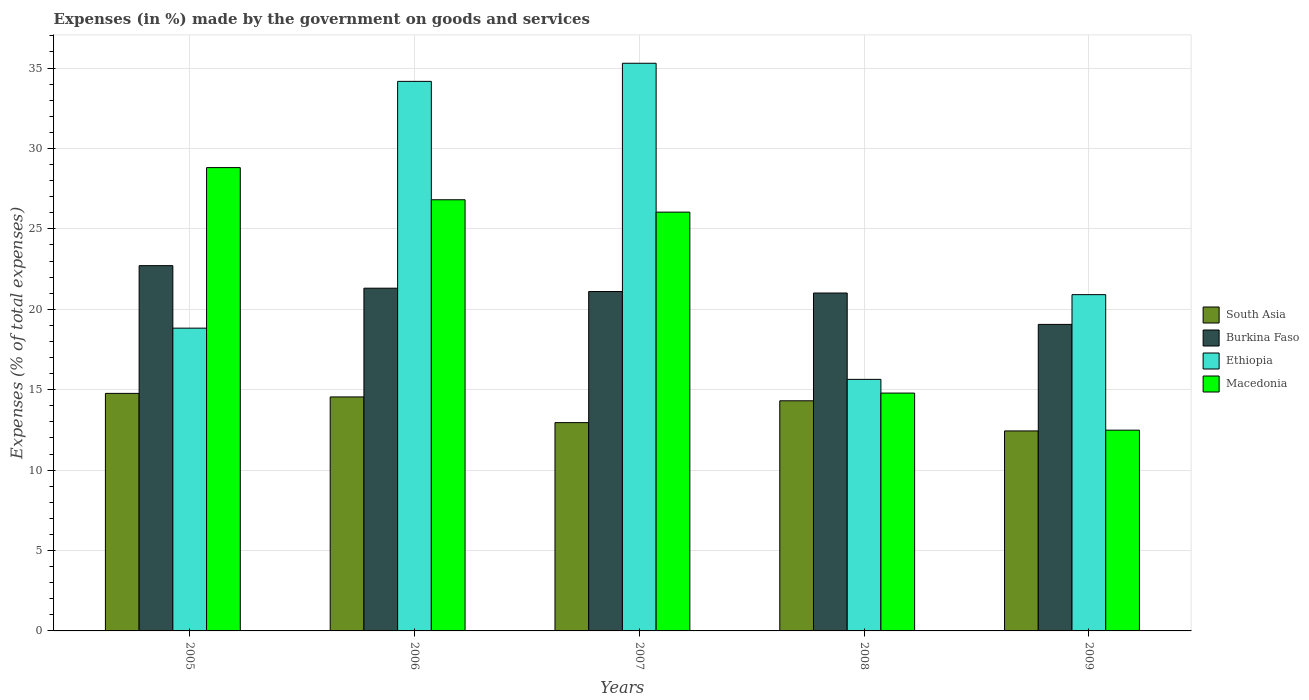How many groups of bars are there?
Make the answer very short. 5. How many bars are there on the 2nd tick from the left?
Offer a very short reply. 4. In how many cases, is the number of bars for a given year not equal to the number of legend labels?
Ensure brevity in your answer.  0. What is the percentage of expenses made by the government on goods and services in South Asia in 2008?
Your answer should be compact. 14.31. Across all years, what is the maximum percentage of expenses made by the government on goods and services in Ethiopia?
Your response must be concise. 35.3. Across all years, what is the minimum percentage of expenses made by the government on goods and services in South Asia?
Offer a terse response. 12.44. What is the total percentage of expenses made by the government on goods and services in Macedonia in the graph?
Provide a short and direct response. 108.93. What is the difference between the percentage of expenses made by the government on goods and services in Macedonia in 2006 and that in 2007?
Give a very brief answer. 0.77. What is the difference between the percentage of expenses made by the government on goods and services in South Asia in 2005 and the percentage of expenses made by the government on goods and services in Ethiopia in 2006?
Offer a very short reply. -19.4. What is the average percentage of expenses made by the government on goods and services in South Asia per year?
Provide a succinct answer. 13.8. In the year 2006, what is the difference between the percentage of expenses made by the government on goods and services in Macedonia and percentage of expenses made by the government on goods and services in Burkina Faso?
Your answer should be very brief. 5.5. In how many years, is the percentage of expenses made by the government on goods and services in Ethiopia greater than 2 %?
Give a very brief answer. 5. What is the ratio of the percentage of expenses made by the government on goods and services in Burkina Faso in 2005 to that in 2008?
Your answer should be compact. 1.08. What is the difference between the highest and the second highest percentage of expenses made by the government on goods and services in South Asia?
Your answer should be very brief. 0.22. What is the difference between the highest and the lowest percentage of expenses made by the government on goods and services in Burkina Faso?
Your answer should be compact. 3.65. Is the sum of the percentage of expenses made by the government on goods and services in South Asia in 2006 and 2009 greater than the maximum percentage of expenses made by the government on goods and services in Macedonia across all years?
Your answer should be compact. No. Is it the case that in every year, the sum of the percentage of expenses made by the government on goods and services in Macedonia and percentage of expenses made by the government on goods and services in South Asia is greater than the sum of percentage of expenses made by the government on goods and services in Ethiopia and percentage of expenses made by the government on goods and services in Burkina Faso?
Make the answer very short. No. What does the 3rd bar from the left in 2009 represents?
Your answer should be compact. Ethiopia. What does the 4th bar from the right in 2005 represents?
Your answer should be compact. South Asia. How many years are there in the graph?
Provide a succinct answer. 5. What is the difference between two consecutive major ticks on the Y-axis?
Provide a short and direct response. 5. Are the values on the major ticks of Y-axis written in scientific E-notation?
Your response must be concise. No. Does the graph contain any zero values?
Your answer should be compact. No. Where does the legend appear in the graph?
Offer a very short reply. Center right. How many legend labels are there?
Offer a very short reply. 4. What is the title of the graph?
Offer a terse response. Expenses (in %) made by the government on goods and services. What is the label or title of the Y-axis?
Offer a terse response. Expenses (% of total expenses). What is the Expenses (% of total expenses) in South Asia in 2005?
Your answer should be very brief. 14.77. What is the Expenses (% of total expenses) in Burkina Faso in 2005?
Give a very brief answer. 22.71. What is the Expenses (% of total expenses) of Ethiopia in 2005?
Give a very brief answer. 18.83. What is the Expenses (% of total expenses) in Macedonia in 2005?
Your answer should be very brief. 28.81. What is the Expenses (% of total expenses) in South Asia in 2006?
Keep it short and to the point. 14.55. What is the Expenses (% of total expenses) in Burkina Faso in 2006?
Provide a succinct answer. 21.31. What is the Expenses (% of total expenses) of Ethiopia in 2006?
Your answer should be very brief. 34.17. What is the Expenses (% of total expenses) of Macedonia in 2006?
Offer a very short reply. 26.81. What is the Expenses (% of total expenses) in South Asia in 2007?
Provide a short and direct response. 12.95. What is the Expenses (% of total expenses) in Burkina Faso in 2007?
Make the answer very short. 21.1. What is the Expenses (% of total expenses) of Ethiopia in 2007?
Offer a very short reply. 35.3. What is the Expenses (% of total expenses) in Macedonia in 2007?
Your response must be concise. 26.04. What is the Expenses (% of total expenses) of South Asia in 2008?
Make the answer very short. 14.31. What is the Expenses (% of total expenses) of Burkina Faso in 2008?
Your answer should be compact. 21.01. What is the Expenses (% of total expenses) in Ethiopia in 2008?
Your answer should be very brief. 15.64. What is the Expenses (% of total expenses) of Macedonia in 2008?
Provide a succinct answer. 14.79. What is the Expenses (% of total expenses) of South Asia in 2009?
Ensure brevity in your answer.  12.44. What is the Expenses (% of total expenses) in Burkina Faso in 2009?
Make the answer very short. 19.06. What is the Expenses (% of total expenses) of Ethiopia in 2009?
Ensure brevity in your answer.  20.91. What is the Expenses (% of total expenses) in Macedonia in 2009?
Make the answer very short. 12.48. Across all years, what is the maximum Expenses (% of total expenses) of South Asia?
Provide a succinct answer. 14.77. Across all years, what is the maximum Expenses (% of total expenses) of Burkina Faso?
Make the answer very short. 22.71. Across all years, what is the maximum Expenses (% of total expenses) in Ethiopia?
Your response must be concise. 35.3. Across all years, what is the maximum Expenses (% of total expenses) in Macedonia?
Give a very brief answer. 28.81. Across all years, what is the minimum Expenses (% of total expenses) of South Asia?
Make the answer very short. 12.44. Across all years, what is the minimum Expenses (% of total expenses) in Burkina Faso?
Keep it short and to the point. 19.06. Across all years, what is the minimum Expenses (% of total expenses) in Ethiopia?
Make the answer very short. 15.64. Across all years, what is the minimum Expenses (% of total expenses) of Macedonia?
Keep it short and to the point. 12.48. What is the total Expenses (% of total expenses) in South Asia in the graph?
Your answer should be compact. 69.01. What is the total Expenses (% of total expenses) in Burkina Faso in the graph?
Keep it short and to the point. 105.19. What is the total Expenses (% of total expenses) in Ethiopia in the graph?
Provide a succinct answer. 124.84. What is the total Expenses (% of total expenses) of Macedonia in the graph?
Give a very brief answer. 108.93. What is the difference between the Expenses (% of total expenses) of South Asia in 2005 and that in 2006?
Keep it short and to the point. 0.22. What is the difference between the Expenses (% of total expenses) in Burkina Faso in 2005 and that in 2006?
Your answer should be compact. 1.4. What is the difference between the Expenses (% of total expenses) in Ethiopia in 2005 and that in 2006?
Provide a short and direct response. -15.34. What is the difference between the Expenses (% of total expenses) in Macedonia in 2005 and that in 2006?
Ensure brevity in your answer.  2. What is the difference between the Expenses (% of total expenses) in South Asia in 2005 and that in 2007?
Give a very brief answer. 1.82. What is the difference between the Expenses (% of total expenses) of Burkina Faso in 2005 and that in 2007?
Your response must be concise. 1.61. What is the difference between the Expenses (% of total expenses) in Ethiopia in 2005 and that in 2007?
Your answer should be compact. -16.47. What is the difference between the Expenses (% of total expenses) in Macedonia in 2005 and that in 2007?
Your response must be concise. 2.77. What is the difference between the Expenses (% of total expenses) of South Asia in 2005 and that in 2008?
Keep it short and to the point. 0.46. What is the difference between the Expenses (% of total expenses) of Burkina Faso in 2005 and that in 2008?
Your response must be concise. 1.7. What is the difference between the Expenses (% of total expenses) in Ethiopia in 2005 and that in 2008?
Your answer should be compact. 3.19. What is the difference between the Expenses (% of total expenses) of Macedonia in 2005 and that in 2008?
Give a very brief answer. 14.02. What is the difference between the Expenses (% of total expenses) in South Asia in 2005 and that in 2009?
Your answer should be very brief. 2.33. What is the difference between the Expenses (% of total expenses) of Burkina Faso in 2005 and that in 2009?
Give a very brief answer. 3.65. What is the difference between the Expenses (% of total expenses) of Ethiopia in 2005 and that in 2009?
Your response must be concise. -2.08. What is the difference between the Expenses (% of total expenses) of Macedonia in 2005 and that in 2009?
Provide a short and direct response. 16.33. What is the difference between the Expenses (% of total expenses) of South Asia in 2006 and that in 2007?
Your response must be concise. 1.6. What is the difference between the Expenses (% of total expenses) in Burkina Faso in 2006 and that in 2007?
Keep it short and to the point. 0.21. What is the difference between the Expenses (% of total expenses) in Ethiopia in 2006 and that in 2007?
Your answer should be compact. -1.13. What is the difference between the Expenses (% of total expenses) in Macedonia in 2006 and that in 2007?
Make the answer very short. 0.77. What is the difference between the Expenses (% of total expenses) of South Asia in 2006 and that in 2008?
Your answer should be compact. 0.24. What is the difference between the Expenses (% of total expenses) of Burkina Faso in 2006 and that in 2008?
Give a very brief answer. 0.3. What is the difference between the Expenses (% of total expenses) in Ethiopia in 2006 and that in 2008?
Offer a terse response. 18.53. What is the difference between the Expenses (% of total expenses) of Macedonia in 2006 and that in 2008?
Provide a succinct answer. 12.02. What is the difference between the Expenses (% of total expenses) of South Asia in 2006 and that in 2009?
Your answer should be very brief. 2.11. What is the difference between the Expenses (% of total expenses) of Burkina Faso in 2006 and that in 2009?
Offer a terse response. 2.25. What is the difference between the Expenses (% of total expenses) of Ethiopia in 2006 and that in 2009?
Make the answer very short. 13.26. What is the difference between the Expenses (% of total expenses) of Macedonia in 2006 and that in 2009?
Keep it short and to the point. 14.33. What is the difference between the Expenses (% of total expenses) of South Asia in 2007 and that in 2008?
Provide a short and direct response. -1.36. What is the difference between the Expenses (% of total expenses) of Burkina Faso in 2007 and that in 2008?
Keep it short and to the point. 0.09. What is the difference between the Expenses (% of total expenses) of Ethiopia in 2007 and that in 2008?
Your response must be concise. 19.65. What is the difference between the Expenses (% of total expenses) in Macedonia in 2007 and that in 2008?
Provide a succinct answer. 11.25. What is the difference between the Expenses (% of total expenses) of South Asia in 2007 and that in 2009?
Provide a succinct answer. 0.52. What is the difference between the Expenses (% of total expenses) of Burkina Faso in 2007 and that in 2009?
Your answer should be very brief. 2.04. What is the difference between the Expenses (% of total expenses) in Ethiopia in 2007 and that in 2009?
Provide a succinct answer. 14.39. What is the difference between the Expenses (% of total expenses) in Macedonia in 2007 and that in 2009?
Your answer should be compact. 13.56. What is the difference between the Expenses (% of total expenses) of South Asia in 2008 and that in 2009?
Make the answer very short. 1.87. What is the difference between the Expenses (% of total expenses) of Burkina Faso in 2008 and that in 2009?
Provide a succinct answer. 1.95. What is the difference between the Expenses (% of total expenses) in Ethiopia in 2008 and that in 2009?
Your response must be concise. -5.27. What is the difference between the Expenses (% of total expenses) in Macedonia in 2008 and that in 2009?
Offer a terse response. 2.31. What is the difference between the Expenses (% of total expenses) in South Asia in 2005 and the Expenses (% of total expenses) in Burkina Faso in 2006?
Your answer should be compact. -6.54. What is the difference between the Expenses (% of total expenses) in South Asia in 2005 and the Expenses (% of total expenses) in Ethiopia in 2006?
Your response must be concise. -19.4. What is the difference between the Expenses (% of total expenses) in South Asia in 2005 and the Expenses (% of total expenses) in Macedonia in 2006?
Your answer should be compact. -12.04. What is the difference between the Expenses (% of total expenses) of Burkina Faso in 2005 and the Expenses (% of total expenses) of Ethiopia in 2006?
Keep it short and to the point. -11.46. What is the difference between the Expenses (% of total expenses) of Burkina Faso in 2005 and the Expenses (% of total expenses) of Macedonia in 2006?
Offer a terse response. -4.1. What is the difference between the Expenses (% of total expenses) in Ethiopia in 2005 and the Expenses (% of total expenses) in Macedonia in 2006?
Your answer should be very brief. -7.98. What is the difference between the Expenses (% of total expenses) in South Asia in 2005 and the Expenses (% of total expenses) in Burkina Faso in 2007?
Give a very brief answer. -6.33. What is the difference between the Expenses (% of total expenses) of South Asia in 2005 and the Expenses (% of total expenses) of Ethiopia in 2007?
Provide a short and direct response. -20.53. What is the difference between the Expenses (% of total expenses) in South Asia in 2005 and the Expenses (% of total expenses) in Macedonia in 2007?
Give a very brief answer. -11.27. What is the difference between the Expenses (% of total expenses) of Burkina Faso in 2005 and the Expenses (% of total expenses) of Ethiopia in 2007?
Offer a very short reply. -12.58. What is the difference between the Expenses (% of total expenses) of Burkina Faso in 2005 and the Expenses (% of total expenses) of Macedonia in 2007?
Make the answer very short. -3.33. What is the difference between the Expenses (% of total expenses) of Ethiopia in 2005 and the Expenses (% of total expenses) of Macedonia in 2007?
Keep it short and to the point. -7.21. What is the difference between the Expenses (% of total expenses) of South Asia in 2005 and the Expenses (% of total expenses) of Burkina Faso in 2008?
Make the answer very short. -6.24. What is the difference between the Expenses (% of total expenses) in South Asia in 2005 and the Expenses (% of total expenses) in Ethiopia in 2008?
Ensure brevity in your answer.  -0.87. What is the difference between the Expenses (% of total expenses) in South Asia in 2005 and the Expenses (% of total expenses) in Macedonia in 2008?
Ensure brevity in your answer.  -0.02. What is the difference between the Expenses (% of total expenses) of Burkina Faso in 2005 and the Expenses (% of total expenses) of Ethiopia in 2008?
Provide a short and direct response. 7.07. What is the difference between the Expenses (% of total expenses) of Burkina Faso in 2005 and the Expenses (% of total expenses) of Macedonia in 2008?
Your response must be concise. 7.92. What is the difference between the Expenses (% of total expenses) of Ethiopia in 2005 and the Expenses (% of total expenses) of Macedonia in 2008?
Give a very brief answer. 4.04. What is the difference between the Expenses (% of total expenses) of South Asia in 2005 and the Expenses (% of total expenses) of Burkina Faso in 2009?
Give a very brief answer. -4.29. What is the difference between the Expenses (% of total expenses) in South Asia in 2005 and the Expenses (% of total expenses) in Ethiopia in 2009?
Keep it short and to the point. -6.14. What is the difference between the Expenses (% of total expenses) in South Asia in 2005 and the Expenses (% of total expenses) in Macedonia in 2009?
Make the answer very short. 2.29. What is the difference between the Expenses (% of total expenses) in Burkina Faso in 2005 and the Expenses (% of total expenses) in Ethiopia in 2009?
Your answer should be compact. 1.8. What is the difference between the Expenses (% of total expenses) of Burkina Faso in 2005 and the Expenses (% of total expenses) of Macedonia in 2009?
Make the answer very short. 10.23. What is the difference between the Expenses (% of total expenses) in Ethiopia in 2005 and the Expenses (% of total expenses) in Macedonia in 2009?
Provide a short and direct response. 6.34. What is the difference between the Expenses (% of total expenses) of South Asia in 2006 and the Expenses (% of total expenses) of Burkina Faso in 2007?
Your response must be concise. -6.55. What is the difference between the Expenses (% of total expenses) of South Asia in 2006 and the Expenses (% of total expenses) of Ethiopia in 2007?
Ensure brevity in your answer.  -20.75. What is the difference between the Expenses (% of total expenses) of South Asia in 2006 and the Expenses (% of total expenses) of Macedonia in 2007?
Make the answer very short. -11.49. What is the difference between the Expenses (% of total expenses) of Burkina Faso in 2006 and the Expenses (% of total expenses) of Ethiopia in 2007?
Your response must be concise. -13.99. What is the difference between the Expenses (% of total expenses) in Burkina Faso in 2006 and the Expenses (% of total expenses) in Macedonia in 2007?
Provide a short and direct response. -4.73. What is the difference between the Expenses (% of total expenses) of Ethiopia in 2006 and the Expenses (% of total expenses) of Macedonia in 2007?
Provide a short and direct response. 8.13. What is the difference between the Expenses (% of total expenses) of South Asia in 2006 and the Expenses (% of total expenses) of Burkina Faso in 2008?
Provide a short and direct response. -6.46. What is the difference between the Expenses (% of total expenses) in South Asia in 2006 and the Expenses (% of total expenses) in Ethiopia in 2008?
Provide a succinct answer. -1.09. What is the difference between the Expenses (% of total expenses) of South Asia in 2006 and the Expenses (% of total expenses) of Macedonia in 2008?
Your answer should be very brief. -0.24. What is the difference between the Expenses (% of total expenses) of Burkina Faso in 2006 and the Expenses (% of total expenses) of Ethiopia in 2008?
Your response must be concise. 5.67. What is the difference between the Expenses (% of total expenses) of Burkina Faso in 2006 and the Expenses (% of total expenses) of Macedonia in 2008?
Ensure brevity in your answer.  6.52. What is the difference between the Expenses (% of total expenses) of Ethiopia in 2006 and the Expenses (% of total expenses) of Macedonia in 2008?
Offer a terse response. 19.38. What is the difference between the Expenses (% of total expenses) of South Asia in 2006 and the Expenses (% of total expenses) of Burkina Faso in 2009?
Your answer should be very brief. -4.51. What is the difference between the Expenses (% of total expenses) in South Asia in 2006 and the Expenses (% of total expenses) in Ethiopia in 2009?
Offer a terse response. -6.36. What is the difference between the Expenses (% of total expenses) in South Asia in 2006 and the Expenses (% of total expenses) in Macedonia in 2009?
Offer a terse response. 2.07. What is the difference between the Expenses (% of total expenses) in Burkina Faso in 2006 and the Expenses (% of total expenses) in Ethiopia in 2009?
Provide a succinct answer. 0.4. What is the difference between the Expenses (% of total expenses) in Burkina Faso in 2006 and the Expenses (% of total expenses) in Macedonia in 2009?
Give a very brief answer. 8.83. What is the difference between the Expenses (% of total expenses) of Ethiopia in 2006 and the Expenses (% of total expenses) of Macedonia in 2009?
Your response must be concise. 21.69. What is the difference between the Expenses (% of total expenses) in South Asia in 2007 and the Expenses (% of total expenses) in Burkina Faso in 2008?
Give a very brief answer. -8.06. What is the difference between the Expenses (% of total expenses) in South Asia in 2007 and the Expenses (% of total expenses) in Ethiopia in 2008?
Provide a succinct answer. -2.69. What is the difference between the Expenses (% of total expenses) in South Asia in 2007 and the Expenses (% of total expenses) in Macedonia in 2008?
Provide a succinct answer. -1.84. What is the difference between the Expenses (% of total expenses) in Burkina Faso in 2007 and the Expenses (% of total expenses) in Ethiopia in 2008?
Ensure brevity in your answer.  5.46. What is the difference between the Expenses (% of total expenses) in Burkina Faso in 2007 and the Expenses (% of total expenses) in Macedonia in 2008?
Your response must be concise. 6.31. What is the difference between the Expenses (% of total expenses) of Ethiopia in 2007 and the Expenses (% of total expenses) of Macedonia in 2008?
Offer a very short reply. 20.51. What is the difference between the Expenses (% of total expenses) in South Asia in 2007 and the Expenses (% of total expenses) in Burkina Faso in 2009?
Ensure brevity in your answer.  -6.11. What is the difference between the Expenses (% of total expenses) of South Asia in 2007 and the Expenses (% of total expenses) of Ethiopia in 2009?
Keep it short and to the point. -7.96. What is the difference between the Expenses (% of total expenses) in South Asia in 2007 and the Expenses (% of total expenses) in Macedonia in 2009?
Make the answer very short. 0.47. What is the difference between the Expenses (% of total expenses) of Burkina Faso in 2007 and the Expenses (% of total expenses) of Ethiopia in 2009?
Keep it short and to the point. 0.19. What is the difference between the Expenses (% of total expenses) in Burkina Faso in 2007 and the Expenses (% of total expenses) in Macedonia in 2009?
Keep it short and to the point. 8.62. What is the difference between the Expenses (% of total expenses) in Ethiopia in 2007 and the Expenses (% of total expenses) in Macedonia in 2009?
Ensure brevity in your answer.  22.81. What is the difference between the Expenses (% of total expenses) in South Asia in 2008 and the Expenses (% of total expenses) in Burkina Faso in 2009?
Make the answer very short. -4.75. What is the difference between the Expenses (% of total expenses) in South Asia in 2008 and the Expenses (% of total expenses) in Macedonia in 2009?
Your answer should be very brief. 1.83. What is the difference between the Expenses (% of total expenses) in Burkina Faso in 2008 and the Expenses (% of total expenses) in Ethiopia in 2009?
Your answer should be very brief. 0.1. What is the difference between the Expenses (% of total expenses) in Burkina Faso in 2008 and the Expenses (% of total expenses) in Macedonia in 2009?
Ensure brevity in your answer.  8.53. What is the difference between the Expenses (% of total expenses) in Ethiopia in 2008 and the Expenses (% of total expenses) in Macedonia in 2009?
Offer a very short reply. 3.16. What is the average Expenses (% of total expenses) of South Asia per year?
Your answer should be very brief. 13.8. What is the average Expenses (% of total expenses) of Burkina Faso per year?
Keep it short and to the point. 21.04. What is the average Expenses (% of total expenses) of Ethiopia per year?
Give a very brief answer. 24.97. What is the average Expenses (% of total expenses) in Macedonia per year?
Your answer should be compact. 21.79. In the year 2005, what is the difference between the Expenses (% of total expenses) of South Asia and Expenses (% of total expenses) of Burkina Faso?
Your response must be concise. -7.94. In the year 2005, what is the difference between the Expenses (% of total expenses) of South Asia and Expenses (% of total expenses) of Ethiopia?
Provide a succinct answer. -4.06. In the year 2005, what is the difference between the Expenses (% of total expenses) of South Asia and Expenses (% of total expenses) of Macedonia?
Make the answer very short. -14.04. In the year 2005, what is the difference between the Expenses (% of total expenses) of Burkina Faso and Expenses (% of total expenses) of Ethiopia?
Your answer should be very brief. 3.89. In the year 2005, what is the difference between the Expenses (% of total expenses) of Burkina Faso and Expenses (% of total expenses) of Macedonia?
Ensure brevity in your answer.  -6.1. In the year 2005, what is the difference between the Expenses (% of total expenses) of Ethiopia and Expenses (% of total expenses) of Macedonia?
Your answer should be very brief. -9.98. In the year 2006, what is the difference between the Expenses (% of total expenses) in South Asia and Expenses (% of total expenses) in Burkina Faso?
Give a very brief answer. -6.76. In the year 2006, what is the difference between the Expenses (% of total expenses) in South Asia and Expenses (% of total expenses) in Ethiopia?
Provide a short and direct response. -19.62. In the year 2006, what is the difference between the Expenses (% of total expenses) of South Asia and Expenses (% of total expenses) of Macedonia?
Provide a short and direct response. -12.26. In the year 2006, what is the difference between the Expenses (% of total expenses) of Burkina Faso and Expenses (% of total expenses) of Ethiopia?
Give a very brief answer. -12.86. In the year 2006, what is the difference between the Expenses (% of total expenses) of Burkina Faso and Expenses (% of total expenses) of Macedonia?
Offer a very short reply. -5.5. In the year 2006, what is the difference between the Expenses (% of total expenses) in Ethiopia and Expenses (% of total expenses) in Macedonia?
Your response must be concise. 7.36. In the year 2007, what is the difference between the Expenses (% of total expenses) of South Asia and Expenses (% of total expenses) of Burkina Faso?
Your answer should be compact. -8.15. In the year 2007, what is the difference between the Expenses (% of total expenses) in South Asia and Expenses (% of total expenses) in Ethiopia?
Your answer should be very brief. -22.34. In the year 2007, what is the difference between the Expenses (% of total expenses) in South Asia and Expenses (% of total expenses) in Macedonia?
Your answer should be compact. -13.09. In the year 2007, what is the difference between the Expenses (% of total expenses) in Burkina Faso and Expenses (% of total expenses) in Ethiopia?
Offer a very short reply. -14.19. In the year 2007, what is the difference between the Expenses (% of total expenses) of Burkina Faso and Expenses (% of total expenses) of Macedonia?
Offer a very short reply. -4.94. In the year 2007, what is the difference between the Expenses (% of total expenses) in Ethiopia and Expenses (% of total expenses) in Macedonia?
Provide a succinct answer. 9.26. In the year 2008, what is the difference between the Expenses (% of total expenses) in South Asia and Expenses (% of total expenses) in Burkina Faso?
Make the answer very short. -6.7. In the year 2008, what is the difference between the Expenses (% of total expenses) in South Asia and Expenses (% of total expenses) in Ethiopia?
Provide a succinct answer. -1.33. In the year 2008, what is the difference between the Expenses (% of total expenses) in South Asia and Expenses (% of total expenses) in Macedonia?
Keep it short and to the point. -0.48. In the year 2008, what is the difference between the Expenses (% of total expenses) in Burkina Faso and Expenses (% of total expenses) in Ethiopia?
Your answer should be very brief. 5.37. In the year 2008, what is the difference between the Expenses (% of total expenses) of Burkina Faso and Expenses (% of total expenses) of Macedonia?
Ensure brevity in your answer.  6.22. In the year 2008, what is the difference between the Expenses (% of total expenses) in Ethiopia and Expenses (% of total expenses) in Macedonia?
Keep it short and to the point. 0.85. In the year 2009, what is the difference between the Expenses (% of total expenses) in South Asia and Expenses (% of total expenses) in Burkina Faso?
Your response must be concise. -6.62. In the year 2009, what is the difference between the Expenses (% of total expenses) of South Asia and Expenses (% of total expenses) of Ethiopia?
Give a very brief answer. -8.47. In the year 2009, what is the difference between the Expenses (% of total expenses) of South Asia and Expenses (% of total expenses) of Macedonia?
Provide a short and direct response. -0.05. In the year 2009, what is the difference between the Expenses (% of total expenses) in Burkina Faso and Expenses (% of total expenses) in Ethiopia?
Your answer should be compact. -1.85. In the year 2009, what is the difference between the Expenses (% of total expenses) in Burkina Faso and Expenses (% of total expenses) in Macedonia?
Ensure brevity in your answer.  6.58. In the year 2009, what is the difference between the Expenses (% of total expenses) of Ethiopia and Expenses (% of total expenses) of Macedonia?
Offer a terse response. 8.43. What is the ratio of the Expenses (% of total expenses) of South Asia in 2005 to that in 2006?
Give a very brief answer. 1.02. What is the ratio of the Expenses (% of total expenses) in Burkina Faso in 2005 to that in 2006?
Make the answer very short. 1.07. What is the ratio of the Expenses (% of total expenses) of Ethiopia in 2005 to that in 2006?
Your answer should be very brief. 0.55. What is the ratio of the Expenses (% of total expenses) in Macedonia in 2005 to that in 2006?
Your answer should be very brief. 1.07. What is the ratio of the Expenses (% of total expenses) in South Asia in 2005 to that in 2007?
Your answer should be very brief. 1.14. What is the ratio of the Expenses (% of total expenses) in Burkina Faso in 2005 to that in 2007?
Provide a succinct answer. 1.08. What is the ratio of the Expenses (% of total expenses) in Ethiopia in 2005 to that in 2007?
Your answer should be very brief. 0.53. What is the ratio of the Expenses (% of total expenses) in Macedonia in 2005 to that in 2007?
Offer a very short reply. 1.11. What is the ratio of the Expenses (% of total expenses) in South Asia in 2005 to that in 2008?
Your answer should be compact. 1.03. What is the ratio of the Expenses (% of total expenses) of Burkina Faso in 2005 to that in 2008?
Offer a very short reply. 1.08. What is the ratio of the Expenses (% of total expenses) of Ethiopia in 2005 to that in 2008?
Your answer should be compact. 1.2. What is the ratio of the Expenses (% of total expenses) of Macedonia in 2005 to that in 2008?
Provide a short and direct response. 1.95. What is the ratio of the Expenses (% of total expenses) in South Asia in 2005 to that in 2009?
Provide a short and direct response. 1.19. What is the ratio of the Expenses (% of total expenses) in Burkina Faso in 2005 to that in 2009?
Give a very brief answer. 1.19. What is the ratio of the Expenses (% of total expenses) of Ethiopia in 2005 to that in 2009?
Provide a succinct answer. 0.9. What is the ratio of the Expenses (% of total expenses) in Macedonia in 2005 to that in 2009?
Make the answer very short. 2.31. What is the ratio of the Expenses (% of total expenses) in South Asia in 2006 to that in 2007?
Ensure brevity in your answer.  1.12. What is the ratio of the Expenses (% of total expenses) of Burkina Faso in 2006 to that in 2007?
Your answer should be very brief. 1.01. What is the ratio of the Expenses (% of total expenses) in Ethiopia in 2006 to that in 2007?
Ensure brevity in your answer.  0.97. What is the ratio of the Expenses (% of total expenses) of Macedonia in 2006 to that in 2007?
Keep it short and to the point. 1.03. What is the ratio of the Expenses (% of total expenses) in South Asia in 2006 to that in 2008?
Provide a succinct answer. 1.02. What is the ratio of the Expenses (% of total expenses) in Burkina Faso in 2006 to that in 2008?
Your response must be concise. 1.01. What is the ratio of the Expenses (% of total expenses) in Ethiopia in 2006 to that in 2008?
Keep it short and to the point. 2.18. What is the ratio of the Expenses (% of total expenses) of Macedonia in 2006 to that in 2008?
Your answer should be very brief. 1.81. What is the ratio of the Expenses (% of total expenses) of South Asia in 2006 to that in 2009?
Keep it short and to the point. 1.17. What is the ratio of the Expenses (% of total expenses) in Burkina Faso in 2006 to that in 2009?
Offer a very short reply. 1.12. What is the ratio of the Expenses (% of total expenses) of Ethiopia in 2006 to that in 2009?
Provide a succinct answer. 1.63. What is the ratio of the Expenses (% of total expenses) in Macedonia in 2006 to that in 2009?
Offer a very short reply. 2.15. What is the ratio of the Expenses (% of total expenses) in South Asia in 2007 to that in 2008?
Offer a terse response. 0.91. What is the ratio of the Expenses (% of total expenses) in Ethiopia in 2007 to that in 2008?
Provide a short and direct response. 2.26. What is the ratio of the Expenses (% of total expenses) of Macedonia in 2007 to that in 2008?
Make the answer very short. 1.76. What is the ratio of the Expenses (% of total expenses) of South Asia in 2007 to that in 2009?
Your answer should be compact. 1.04. What is the ratio of the Expenses (% of total expenses) of Burkina Faso in 2007 to that in 2009?
Provide a succinct answer. 1.11. What is the ratio of the Expenses (% of total expenses) of Ethiopia in 2007 to that in 2009?
Give a very brief answer. 1.69. What is the ratio of the Expenses (% of total expenses) in Macedonia in 2007 to that in 2009?
Make the answer very short. 2.09. What is the ratio of the Expenses (% of total expenses) of South Asia in 2008 to that in 2009?
Your response must be concise. 1.15. What is the ratio of the Expenses (% of total expenses) of Burkina Faso in 2008 to that in 2009?
Your answer should be compact. 1.1. What is the ratio of the Expenses (% of total expenses) in Ethiopia in 2008 to that in 2009?
Offer a very short reply. 0.75. What is the ratio of the Expenses (% of total expenses) in Macedonia in 2008 to that in 2009?
Your answer should be compact. 1.18. What is the difference between the highest and the second highest Expenses (% of total expenses) of South Asia?
Your response must be concise. 0.22. What is the difference between the highest and the second highest Expenses (% of total expenses) of Burkina Faso?
Your answer should be compact. 1.4. What is the difference between the highest and the second highest Expenses (% of total expenses) of Ethiopia?
Ensure brevity in your answer.  1.13. What is the difference between the highest and the second highest Expenses (% of total expenses) of Macedonia?
Keep it short and to the point. 2. What is the difference between the highest and the lowest Expenses (% of total expenses) in South Asia?
Provide a succinct answer. 2.33. What is the difference between the highest and the lowest Expenses (% of total expenses) of Burkina Faso?
Your answer should be compact. 3.65. What is the difference between the highest and the lowest Expenses (% of total expenses) in Ethiopia?
Keep it short and to the point. 19.65. What is the difference between the highest and the lowest Expenses (% of total expenses) of Macedonia?
Offer a very short reply. 16.33. 